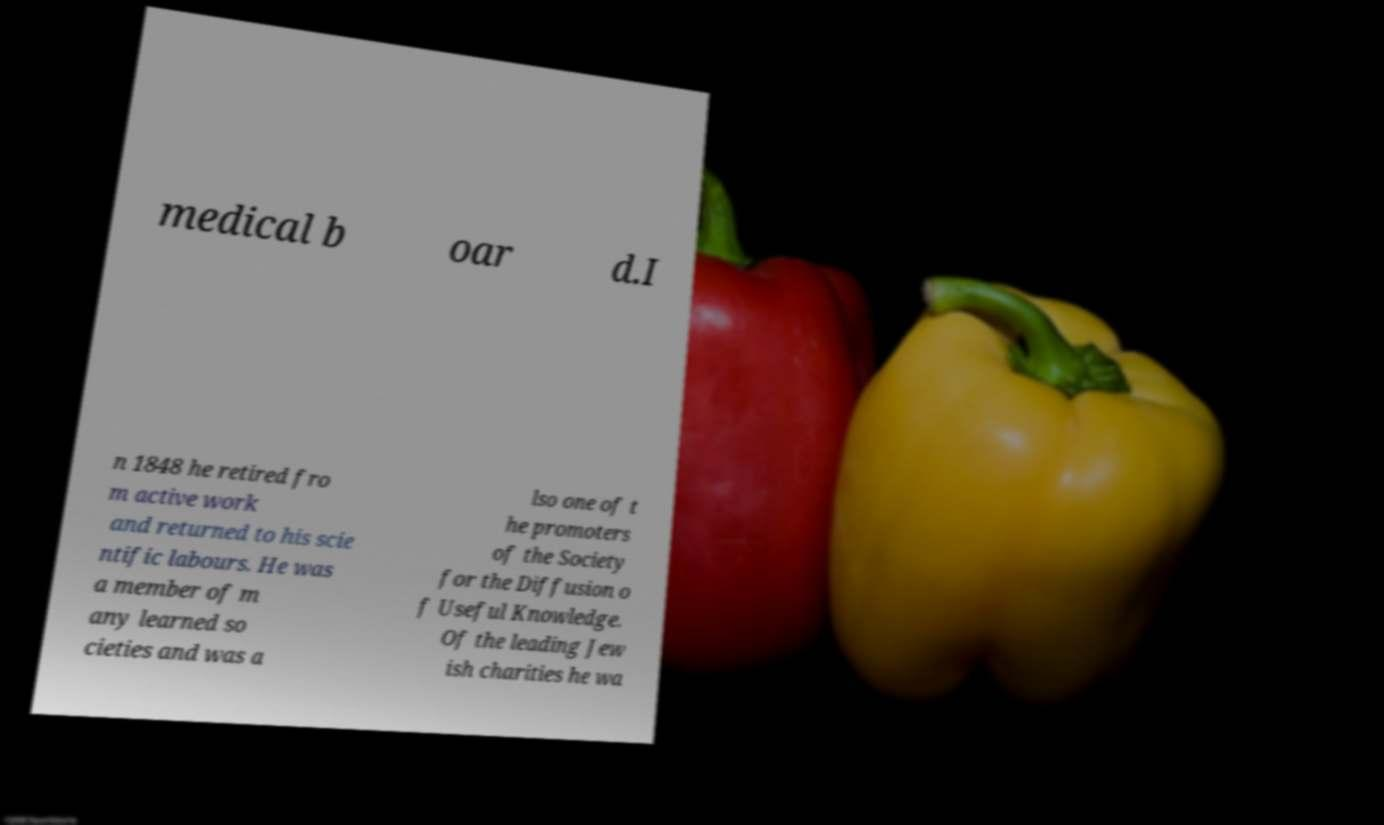Could you extract and type out the text from this image? medical b oar d.I n 1848 he retired fro m active work and returned to his scie ntific labours. He was a member of m any learned so cieties and was a lso one of t he promoters of the Society for the Diffusion o f Useful Knowledge. Of the leading Jew ish charities he wa 